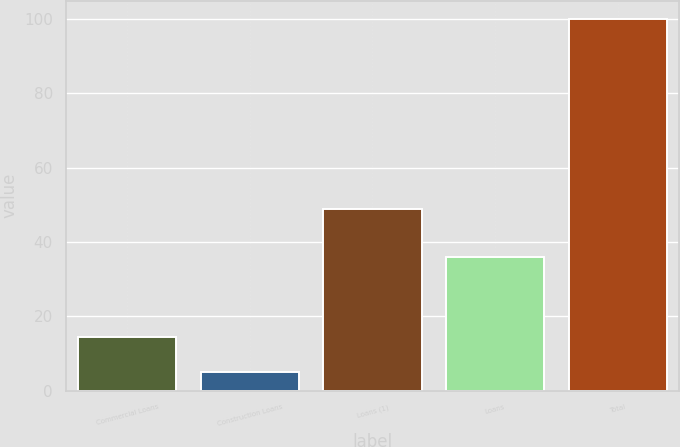<chart> <loc_0><loc_0><loc_500><loc_500><bar_chart><fcel>Commercial Loans<fcel>Construction Loans<fcel>Loans (1)<fcel>Loans<fcel>Total<nl><fcel>14.5<fcel>5<fcel>49<fcel>36<fcel>100<nl></chart> 